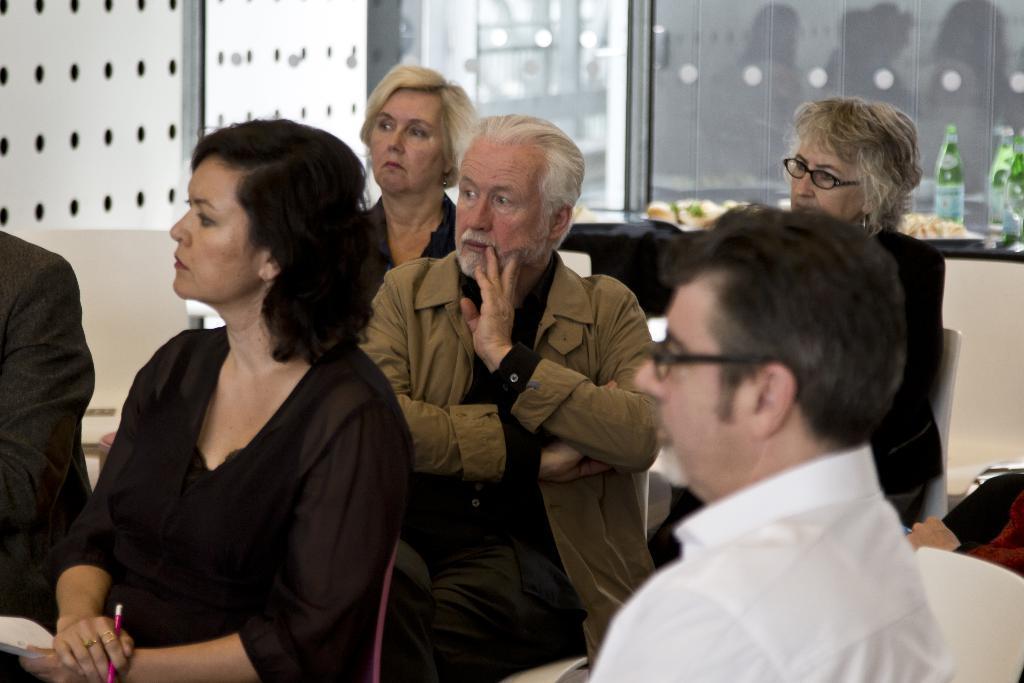Can you describe this image briefly? People are sitting in a room. The person at the right is wearing a white shirt. There are glass bottles and food items at the back. 